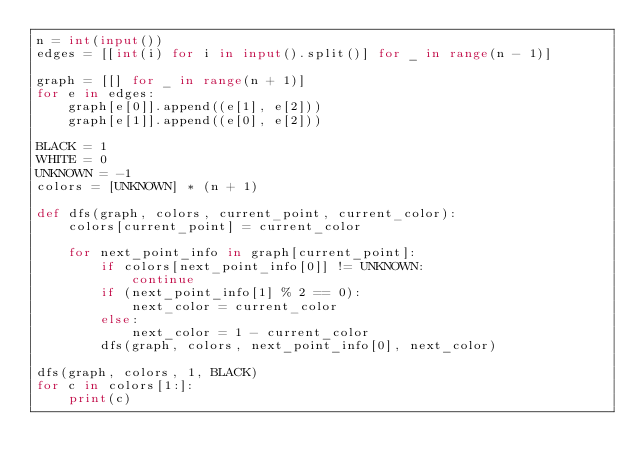Convert code to text. <code><loc_0><loc_0><loc_500><loc_500><_Python_>n = int(input())
edges = [[int(i) for i in input().split()] for _ in range(n - 1)]

graph = [[] for _ in range(n + 1)]
for e in edges:
    graph[e[0]].append((e[1], e[2]))
    graph[e[1]].append((e[0], e[2]))

BLACK = 1
WHITE = 0
UNKNOWN = -1
colors = [UNKNOWN] * (n + 1)

def dfs(graph, colors, current_point, current_color):
    colors[current_point] = current_color

    for next_point_info in graph[current_point]:
        if colors[next_point_info[0]] != UNKNOWN:
            continue
        if (next_point_info[1] % 2 == 0):
            next_color = current_color
        else:
            next_color = 1 - current_color
        dfs(graph, colors, next_point_info[0], next_color)

dfs(graph, colors, 1, BLACK)
for c in colors[1:]:
    print(c)
</code> 